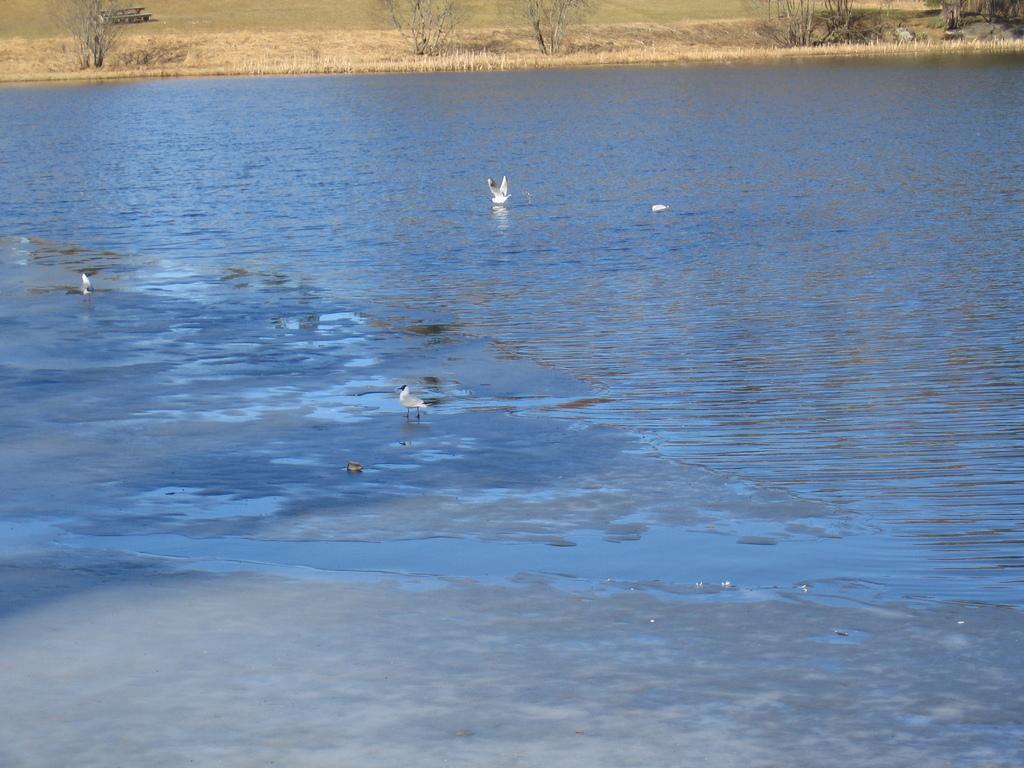Could you give a brief overview of what you see in this image? In this image I can see water, grass and few white colour birds. 